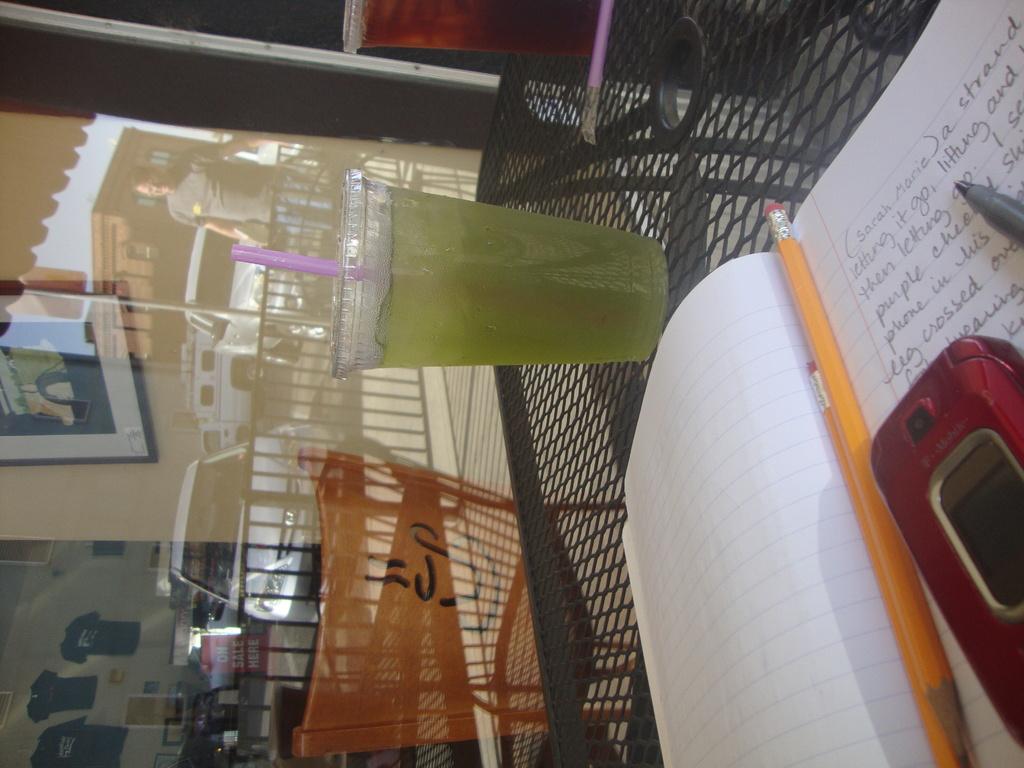What name is written at the top of the page?
Give a very brief answer. Sarah marie. 